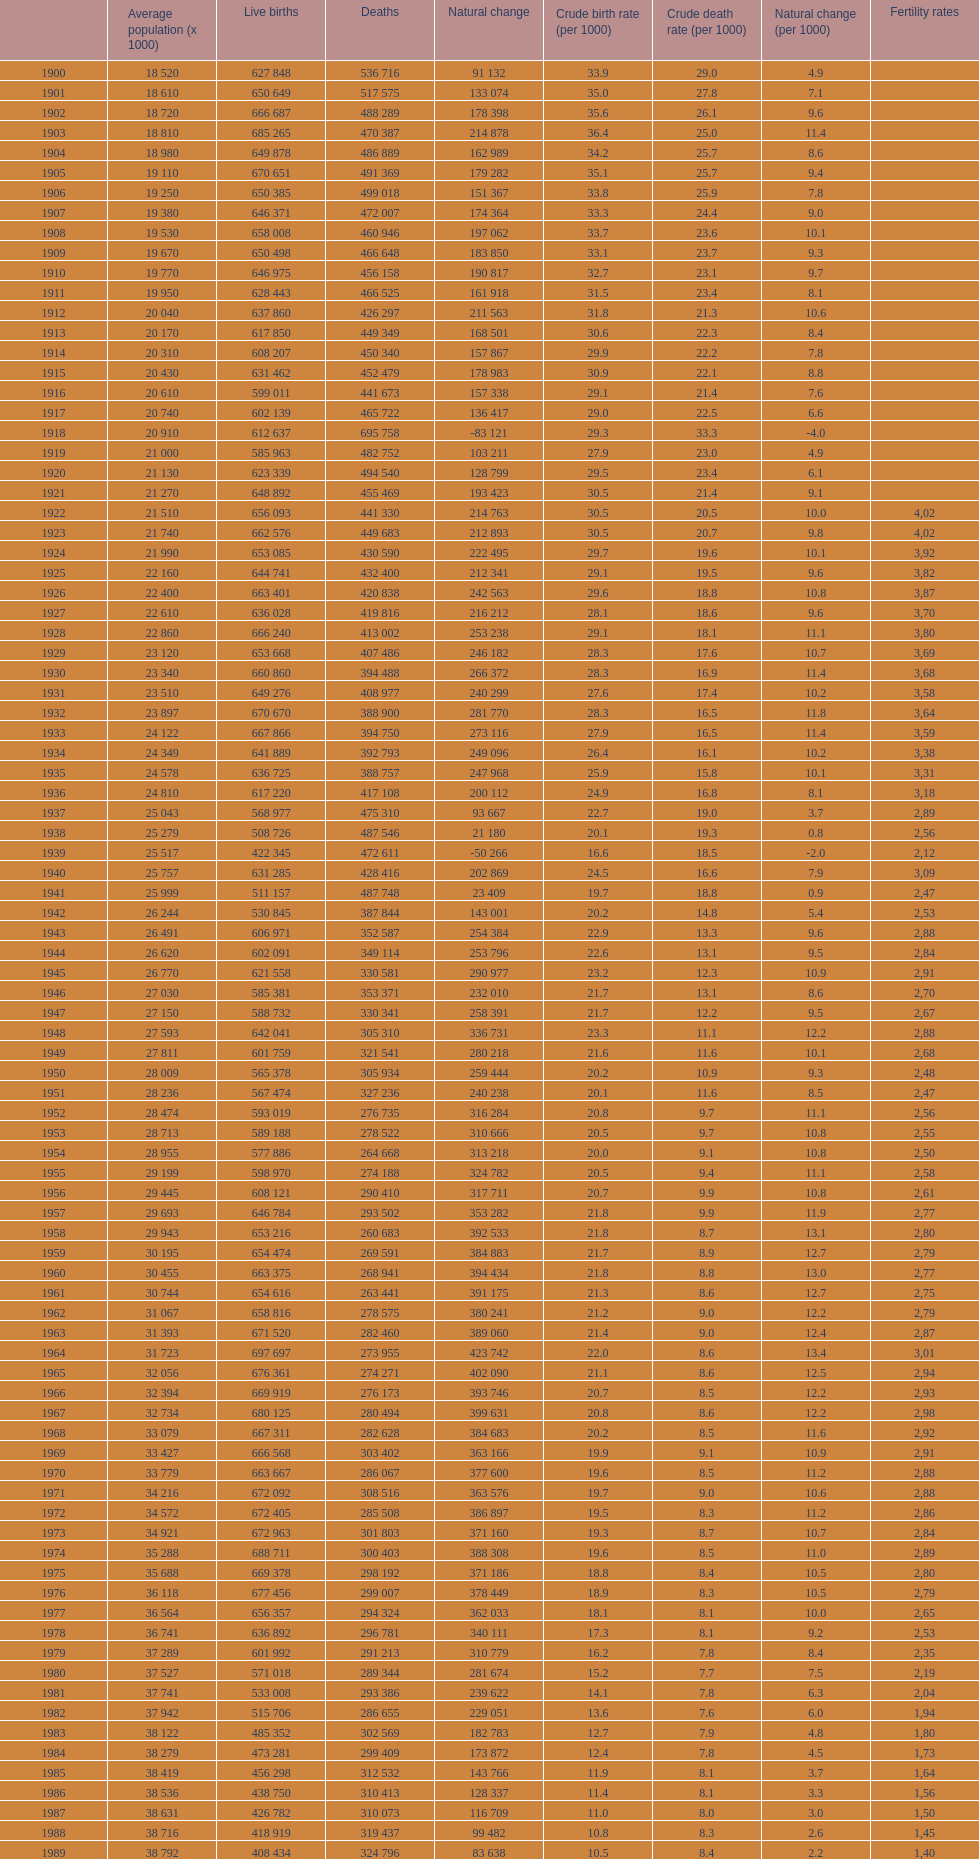Which year has a crude birth rate of 29.1 with a population of 22,860? 1928. 